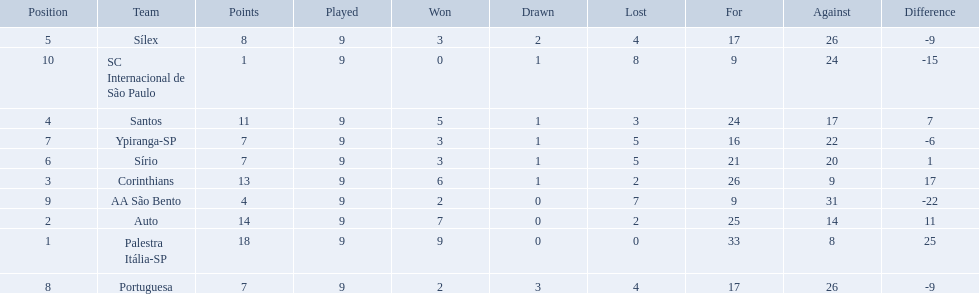What are all the teams? Palestra Itália-SP, Auto, Corinthians, Santos, Sílex, Sírio, Ypiranga-SP, Portuguesa, AA São Bento, SC Internacional de São Paulo. How many times did each team lose? 0, 2, 2, 3, 4, 5, 5, 4, 7, 8. And which team never lost? Palestra Itália-SP. 